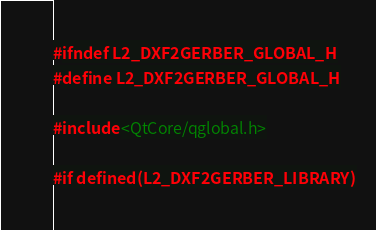<code> <loc_0><loc_0><loc_500><loc_500><_C_>#ifndef L2_DXF2GERBER_GLOBAL_H
#define L2_DXF2GERBER_GLOBAL_H

#include <QtCore/qglobal.h>

#if defined(L2_DXF2GERBER_LIBRARY)</code> 